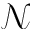Convert formula to latex. <formula><loc_0><loc_0><loc_500><loc_500>\mathcal { N }</formula> 